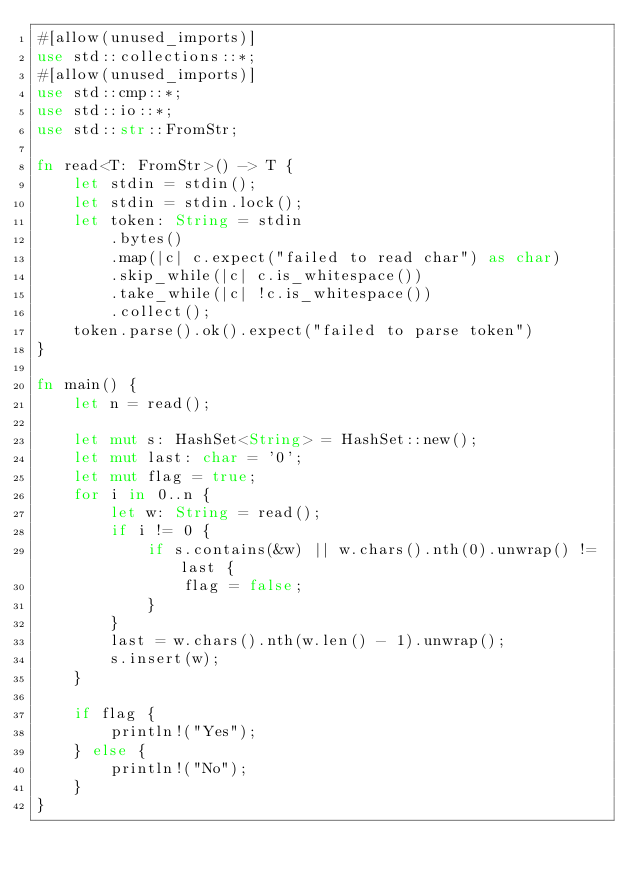Convert code to text. <code><loc_0><loc_0><loc_500><loc_500><_Rust_>#[allow(unused_imports)]
use std::collections::*;
#[allow(unused_imports)]
use std::cmp::*;
use std::io::*;
use std::str::FromStr;

fn read<T: FromStr>() -> T {
    let stdin = stdin();
    let stdin = stdin.lock();
    let token: String = stdin
        .bytes()
        .map(|c| c.expect("failed to read char") as char)
        .skip_while(|c| c.is_whitespace())
        .take_while(|c| !c.is_whitespace())
        .collect();
    token.parse().ok().expect("failed to parse token")
}

fn main() {
    let n = read();

    let mut s: HashSet<String> = HashSet::new();
    let mut last: char = '0';
    let mut flag = true;
    for i in 0..n {
        let w: String = read();
        if i != 0 {
            if s.contains(&w) || w.chars().nth(0).unwrap() != last {
                flag = false;
            }
        }
        last = w.chars().nth(w.len() - 1).unwrap();
        s.insert(w);
    }

    if flag {
        println!("Yes");
    } else {
        println!("No");
    }
}</code> 